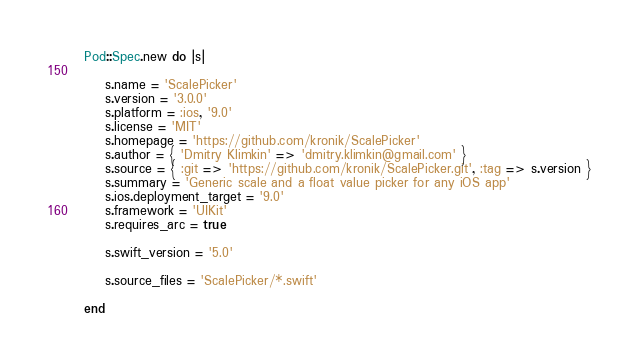Convert code to text. <code><loc_0><loc_0><loc_500><loc_500><_Ruby_>Pod::Spec.new do |s|

    s.name = 'ScalePicker'
    s.version = '3.0.0'
    s.platform = :ios, '9.0'
    s.license = 'MIT'
    s.homepage = 'https://github.com/kronik/ScalePicker'
    s.author = { 'Dmitry Klimkin' => 'dmitry.klimkin@gmail.com' }
    s.source = { :git => 'https://github.com/kronik/ScalePicker.git', :tag => s.version }
    s.summary = 'Generic scale and a float value picker for any iOS app'
    s.ios.deployment_target = '9.0'
    s.framework = 'UIKit'
    s.requires_arc = true

    s.swift_version = '5.0'

    s.source_files = 'ScalePicker/*.swift'

end
</code> 